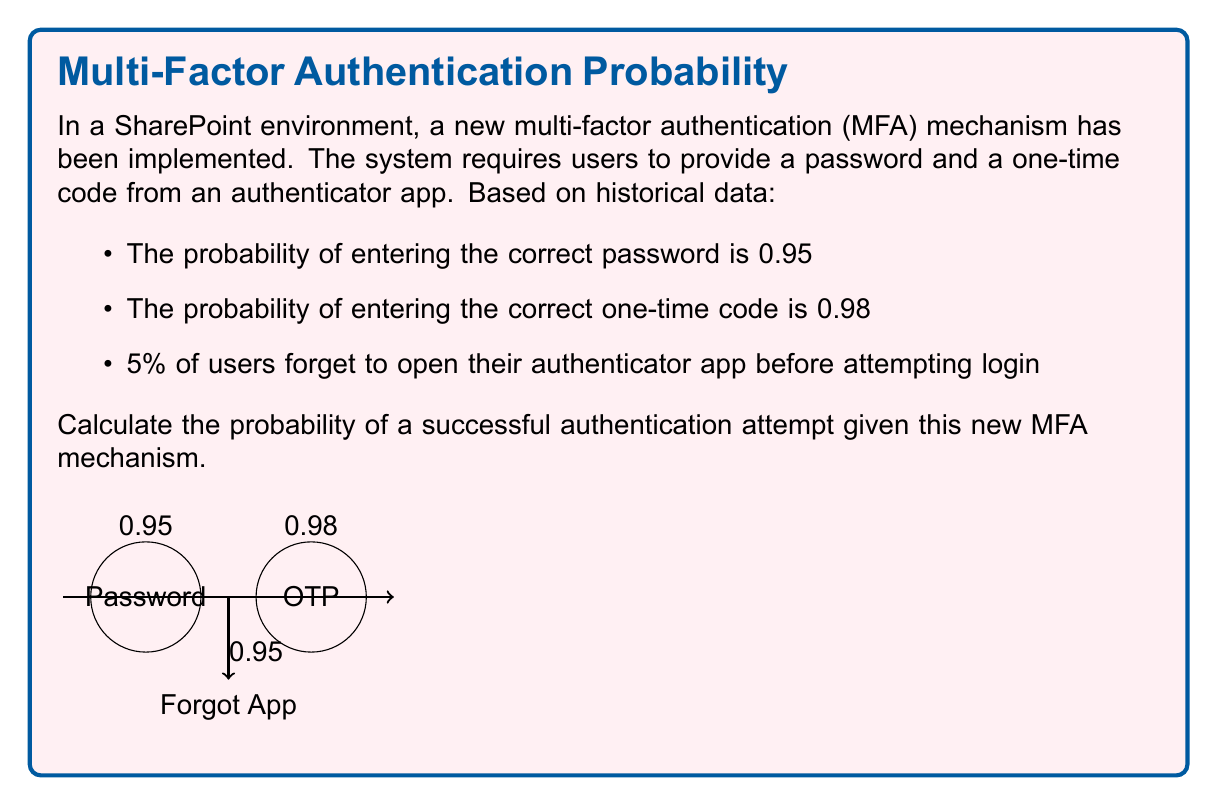Help me with this question. Let's approach this step-by-step:

1) For a successful authentication, three conditions must be met:
   a) The user must remember to open the authenticator app
   b) The password must be entered correctly
   c) The one-time code must be entered correctly

2) Let's define events:
   A: User remembers to open the app
   B: Correct password entry
   C: Correct one-time code entry

3) We're given:
   P(A) = 1 - 0.05 = 0.95 (since 5% forget)
   P(B) = 0.95
   P(C) = 0.98

4) For a successful authentication, we need the probability of (A and B and C)

5) Assuming these events are independent:
   P(Successful Authentication) = P(A) × P(B) × P(C)

6) Calculating:
   P(Successful Authentication) = 0.95 × 0.95 × 0.98

7) Computing:
   P(Successful Authentication) = 0.88445

Therefore, the probability of a successful authentication attempt is approximately 0.8845 or 88.45%.
Answer: $$0.88445$$ 